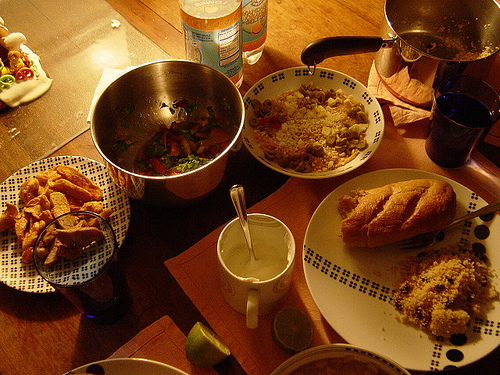<image>
Can you confirm if the plate is in front of the lemon? Yes. The plate is positioned in front of the lemon, appearing closer to the camera viewpoint. 